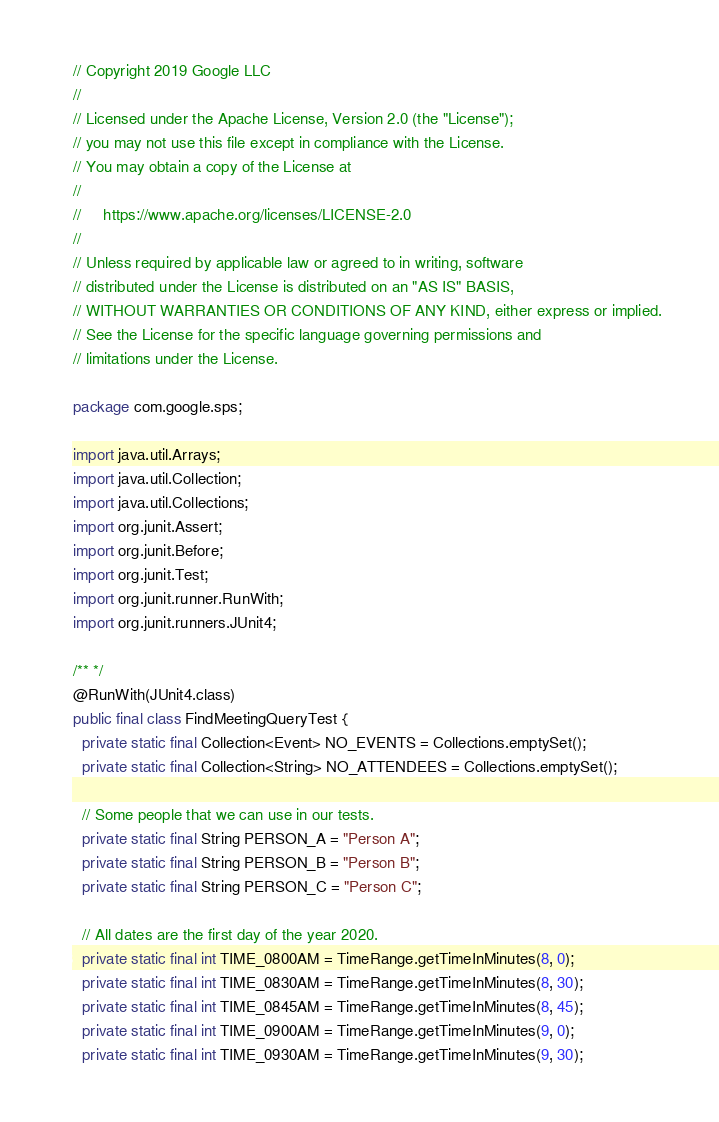<code> <loc_0><loc_0><loc_500><loc_500><_Java_>// Copyright 2019 Google LLC
//
// Licensed under the Apache License, Version 2.0 (the "License");
// you may not use this file except in compliance with the License.
// You may obtain a copy of the License at
//
//     https://www.apache.org/licenses/LICENSE-2.0
//
// Unless required by applicable law or agreed to in writing, software
// distributed under the License is distributed on an "AS IS" BASIS,
// WITHOUT WARRANTIES OR CONDITIONS OF ANY KIND, either express or implied.
// See the License for the specific language governing permissions and
// limitations under the License.

package com.google.sps;

import java.util.Arrays;
import java.util.Collection;
import java.util.Collections;
import org.junit.Assert;
import org.junit.Before;
import org.junit.Test;
import org.junit.runner.RunWith;
import org.junit.runners.JUnit4;

/** */
@RunWith(JUnit4.class)
public final class FindMeetingQueryTest {
  private static final Collection<Event> NO_EVENTS = Collections.emptySet();
  private static final Collection<String> NO_ATTENDEES = Collections.emptySet();

  // Some people that we can use in our tests.
  private static final String PERSON_A = "Person A";
  private static final String PERSON_B = "Person B";
  private static final String PERSON_C = "Person C";

  // All dates are the first day of the year 2020.
  private static final int TIME_0800AM = TimeRange.getTimeInMinutes(8, 0);
  private static final int TIME_0830AM = TimeRange.getTimeInMinutes(8, 30);
  private static final int TIME_0845AM = TimeRange.getTimeInMinutes(8, 45);
  private static final int TIME_0900AM = TimeRange.getTimeInMinutes(9, 0);
  private static final int TIME_0930AM = TimeRange.getTimeInMinutes(9, 30);</code> 